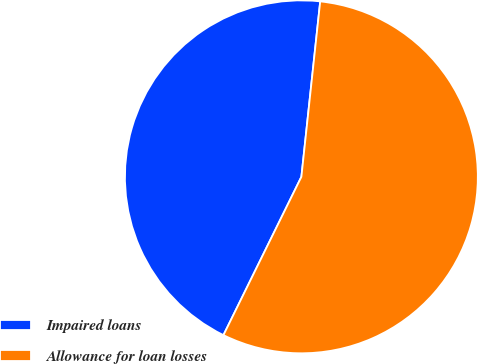Convert chart to OTSL. <chart><loc_0><loc_0><loc_500><loc_500><pie_chart><fcel>Impaired loans<fcel>Allowance for loan losses<nl><fcel>44.42%<fcel>55.58%<nl></chart> 